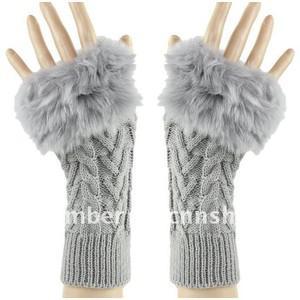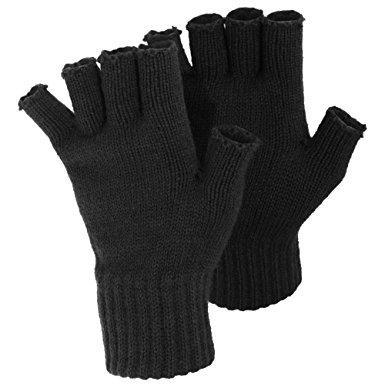The first image is the image on the left, the second image is the image on the right. Evaluate the accuracy of this statement regarding the images: "One image includes at least one pair of half-finger gloves with a mitten flap, and the other image shows one pair of knit mittens with fur cuffs at the wrists.". Is it true? Answer yes or no. No. 